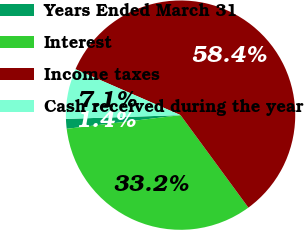Convert chart. <chart><loc_0><loc_0><loc_500><loc_500><pie_chart><fcel>Years Ended March 31<fcel>Interest<fcel>Income taxes<fcel>Cash received during the year<nl><fcel>1.38%<fcel>33.17%<fcel>58.37%<fcel>7.08%<nl></chart> 